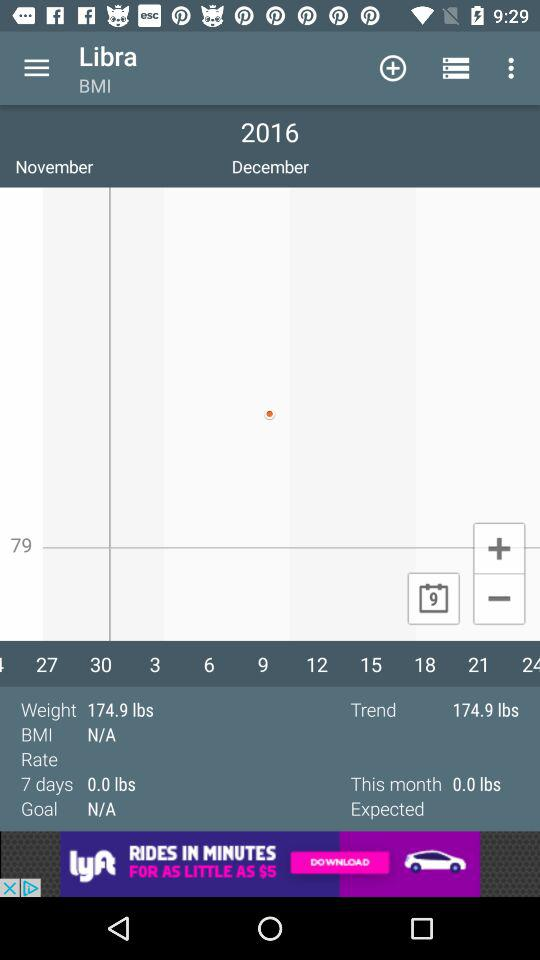What is the goal? The goal is N/A. 